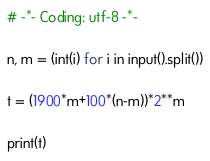Convert code to text. <code><loc_0><loc_0><loc_500><loc_500><_Python_># -*- Coding: utf-8 -*-

n, m = (int(i) for i in input().split())

t = (1900*m+100*(n-m))*2**m

print(t)</code> 